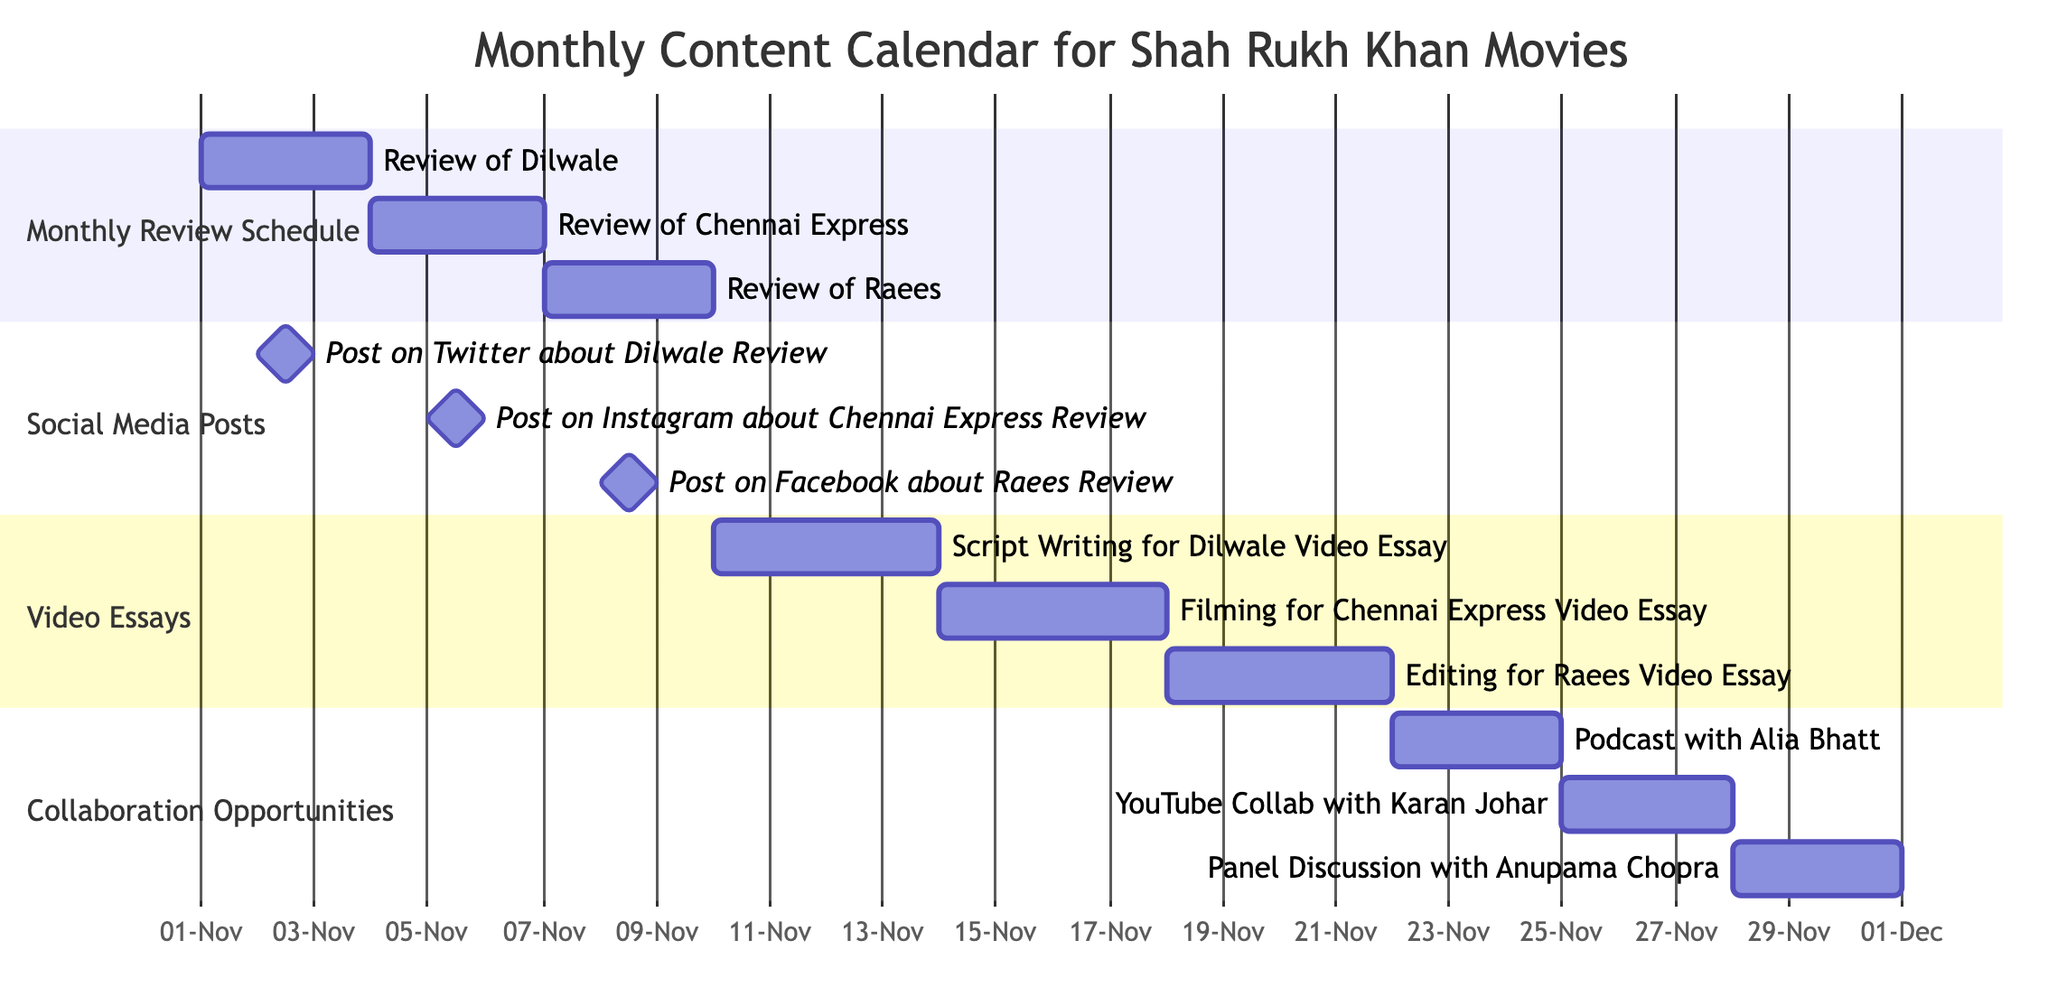What is the duration of the "Review of Dilwale"? The "Review of Dilwale" starts on November 1, 2023, and ends on November 3, 2023. This gives a duration of 3 days.
Answer: 3 days When is the "Post on Twitter about Dilwale Review" scheduled? The "Post on Twitter about Dilwale Review" is scheduled for November 2, 2023, as indicated in the diagram.
Answer: November 2, 2023 How many video essays are planned in this content calendar? There are three video essays planned: one for Dilwale, one for Chennai Express, and one for Raees.
Answer: 3 Which task has the first start date in the calendar? The "Monthly Review Schedule" task starts first with the "Review of Dilwale" on November 1, 2023.
Answer: Monthly Review Schedule What is the last end date in the calendar? The last end date in the calendar is November 30, 2023, for the "Panel Discussion with Anupama Chopra."
Answer: November 30, 2023 Which collaboration opportunity occurs after November 25, 2023? The "Panel Discussion with Anupama Chopra" occurs after November 25, 2023, starting on November 28, 2023.
Answer: Panel Discussion with Anupama Chopra Which movie's video essay is scheduled for the longest duration? The "Script Writing for Dilwale Video Essay" has the longest duration, lasting 4 days from November 10 to November 13, 2023.
Answer: Script Writing for Dilwale Video Essay What is the relationship between the "Review of Raees" and the "Post on Facebook about Raees Review"? The "Review of Raees" ends on November 9, 2023, and the "Post on Facebook about Raees Review" is scheduled for November 8, 2023, so they are closely related within the monthly review schedule.
Answer: Closely related 